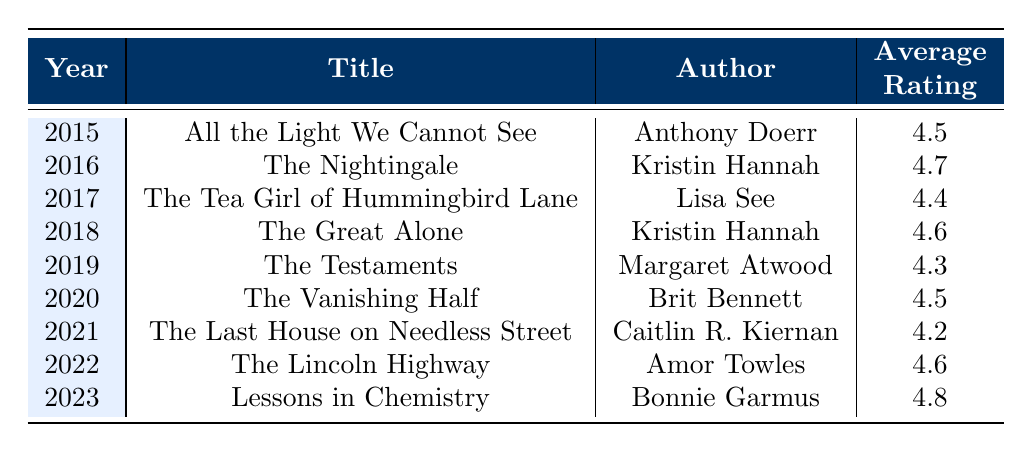What is the average rating for the book "The Nightingale"? The table shows that "The Nightingale," published in 2016, has an average rating of 4.7. This is explicitly mentioned in the column for average ratings.
Answer: 4.7 Which book published in 2021 has the lowest average rating? From the table, "The Last House on Needless Street" published in 2021 has the lowest average rating of 4.2 compared to other books for that year.
Answer: The Last House on Needless Street How many reviews does "The Lincoln Highway" have? According to the table, "The Lincoln Highway," which was published in 2022, has 4500 reviews listed in the corresponding column.
Answer: 4500 Is "Lessons in Chemistry" rated higher than "The Great Alone"? "Lessons in Chemistry," published in 2023, has a rating of 4.8, while "The Great Alone," published in 2018, has a rating of 4.6. Since 4.8 is greater than 4.6, the statement is true.
Answer: Yes What is the total number of reviews for novels published in 2019 and 2020? The number of reviews for "The Testaments" published in 2019 is 11000 and for "The Vanishing Half" in 2020 is 7800. When summed, the total is 11000 + 7800 = 18800.
Answer: 18800 Which author has the highest average rating from their published book in this table? The author with the highest average rating from the table is Bonnie Garmus, who wrote "Lessons in Chemistry" in 2023 with a rating of 4.8. No other author has a higher rating in this selection of books.
Answer: Bonnie Garmus What is the difference in average ratings between the best and worst-rated books in the table? The best rating in the table is 4.8 from "Lessons in Chemistry," and the worst is 4.2 from "The Last House on Needless Street." The difference is calculated as 4.8 - 4.2 = 0.6.
Answer: 0.6 How many books in the table received an average rating of 4.5 or above? By reviewing the ratings, the books that have an average rating of 4.5 or above are: "All the Light We Cannot See," "The Nightingale," "The Great Alone," "The Vanishing Half," "The Lincoln Highway," and "Lessons in Chemistry." This totals 6 books.
Answer: 6 Is there a book with the same number of reviews as "The Testaments"? "The Testaments" has 11000 reviews. No other book in the table shares this exact number, as the next closest count is from "All the Light We Cannot See" with 12000 reviews. Thus, the answer is no.
Answer: No 